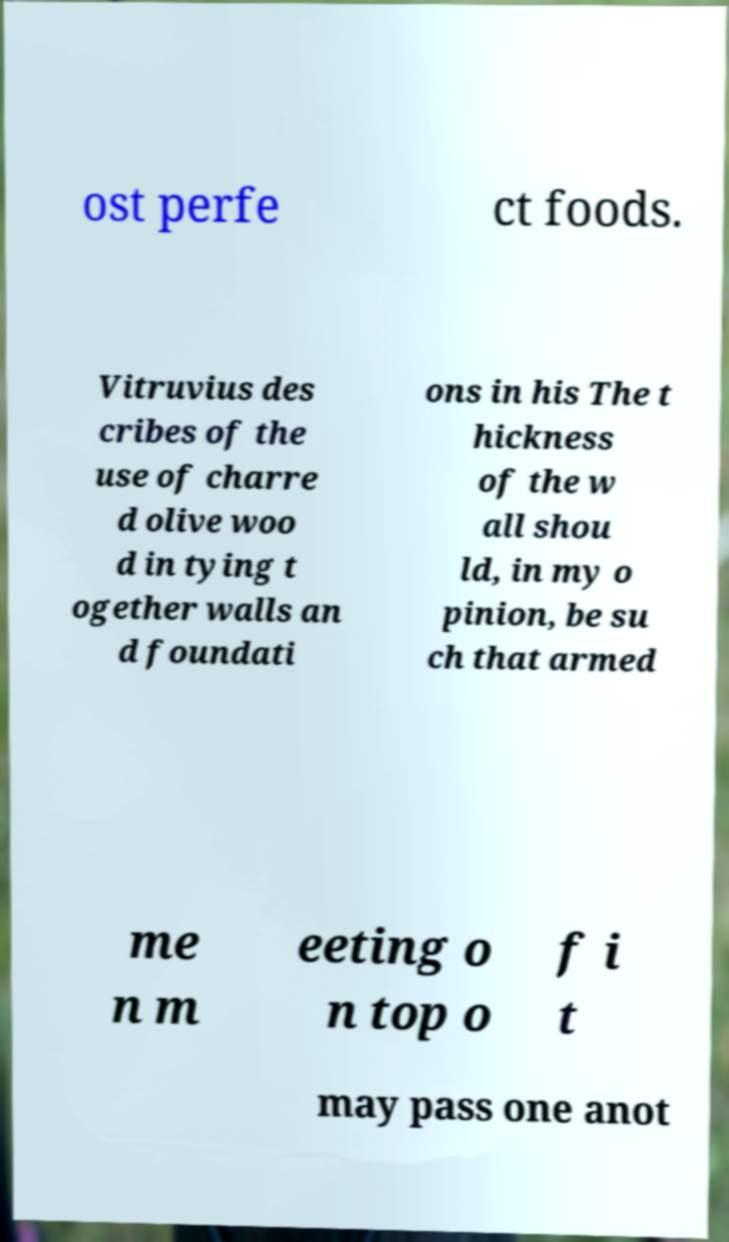I need the written content from this picture converted into text. Can you do that? ost perfe ct foods. Vitruvius des cribes of the use of charre d olive woo d in tying t ogether walls an d foundati ons in his The t hickness of the w all shou ld, in my o pinion, be su ch that armed me n m eeting o n top o f i t may pass one anot 